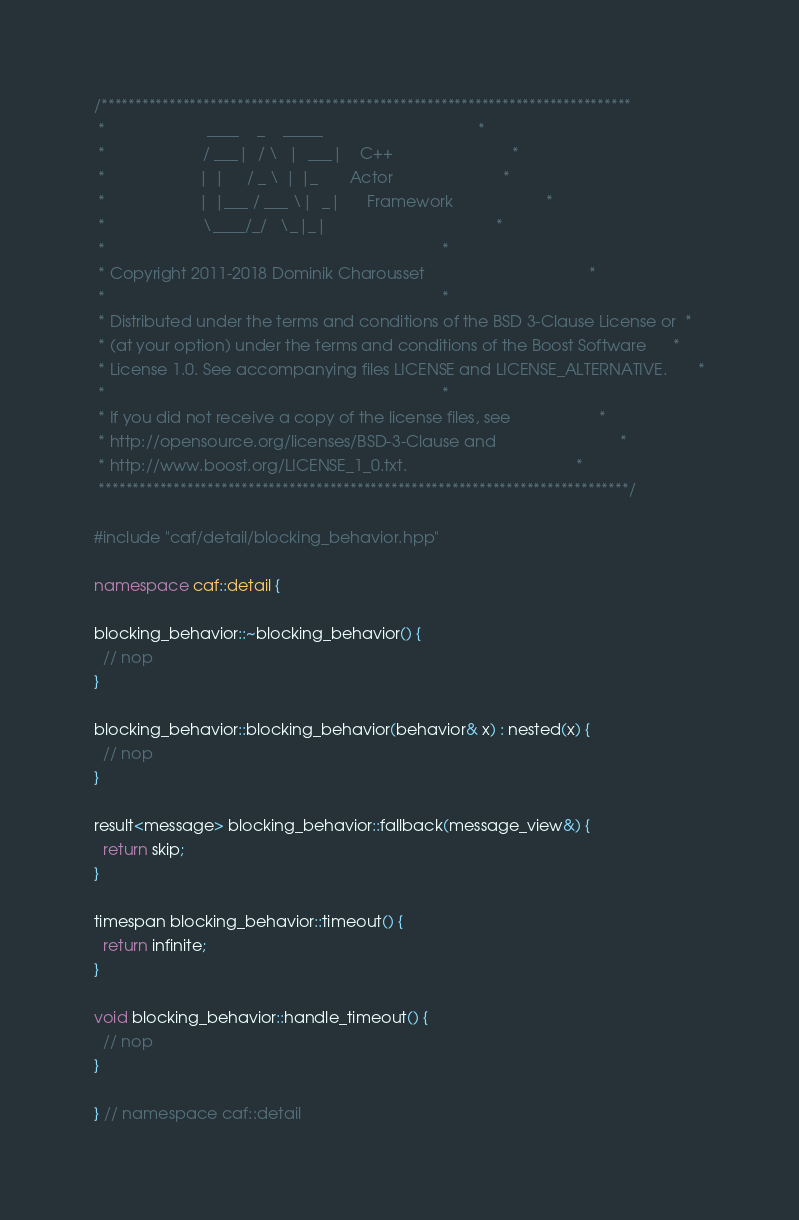<code> <loc_0><loc_0><loc_500><loc_500><_C++_>/******************************************************************************
 *                       ____    _    _____                                   *
 *                      / ___|  / \  |  ___|    C++                           *
 *                     | |     / _ \ | |_       Actor                         *
 *                     | |___ / ___ \|  _|      Framework                     *
 *                      \____/_/   \_|_|                                      *
 *                                                                            *
 * Copyright 2011-2018 Dominik Charousset                                     *
 *                                                                            *
 * Distributed under the terms and conditions of the BSD 3-Clause License or  *
 * (at your option) under the terms and conditions of the Boost Software      *
 * License 1.0. See accompanying files LICENSE and LICENSE_ALTERNATIVE.       *
 *                                                                            *
 * If you did not receive a copy of the license files, see                    *
 * http://opensource.org/licenses/BSD-3-Clause and                            *
 * http://www.boost.org/LICENSE_1_0.txt.                                      *
 ******************************************************************************/

#include "caf/detail/blocking_behavior.hpp"

namespace caf::detail {

blocking_behavior::~blocking_behavior() {
  // nop
}

blocking_behavior::blocking_behavior(behavior& x) : nested(x) {
  // nop
}

result<message> blocking_behavior::fallback(message_view&) {
  return skip;
}

timespan blocking_behavior::timeout() {
  return infinite;
}

void blocking_behavior::handle_timeout() {
  // nop
}

} // namespace caf::detail
</code> 